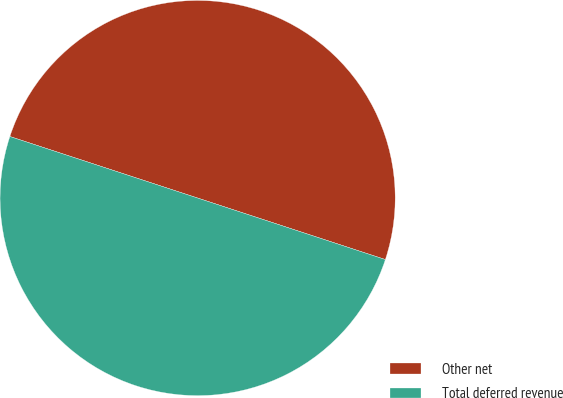<chart> <loc_0><loc_0><loc_500><loc_500><pie_chart><fcel>Other net<fcel>Total deferred revenue<nl><fcel>50.0%<fcel>50.0%<nl></chart> 